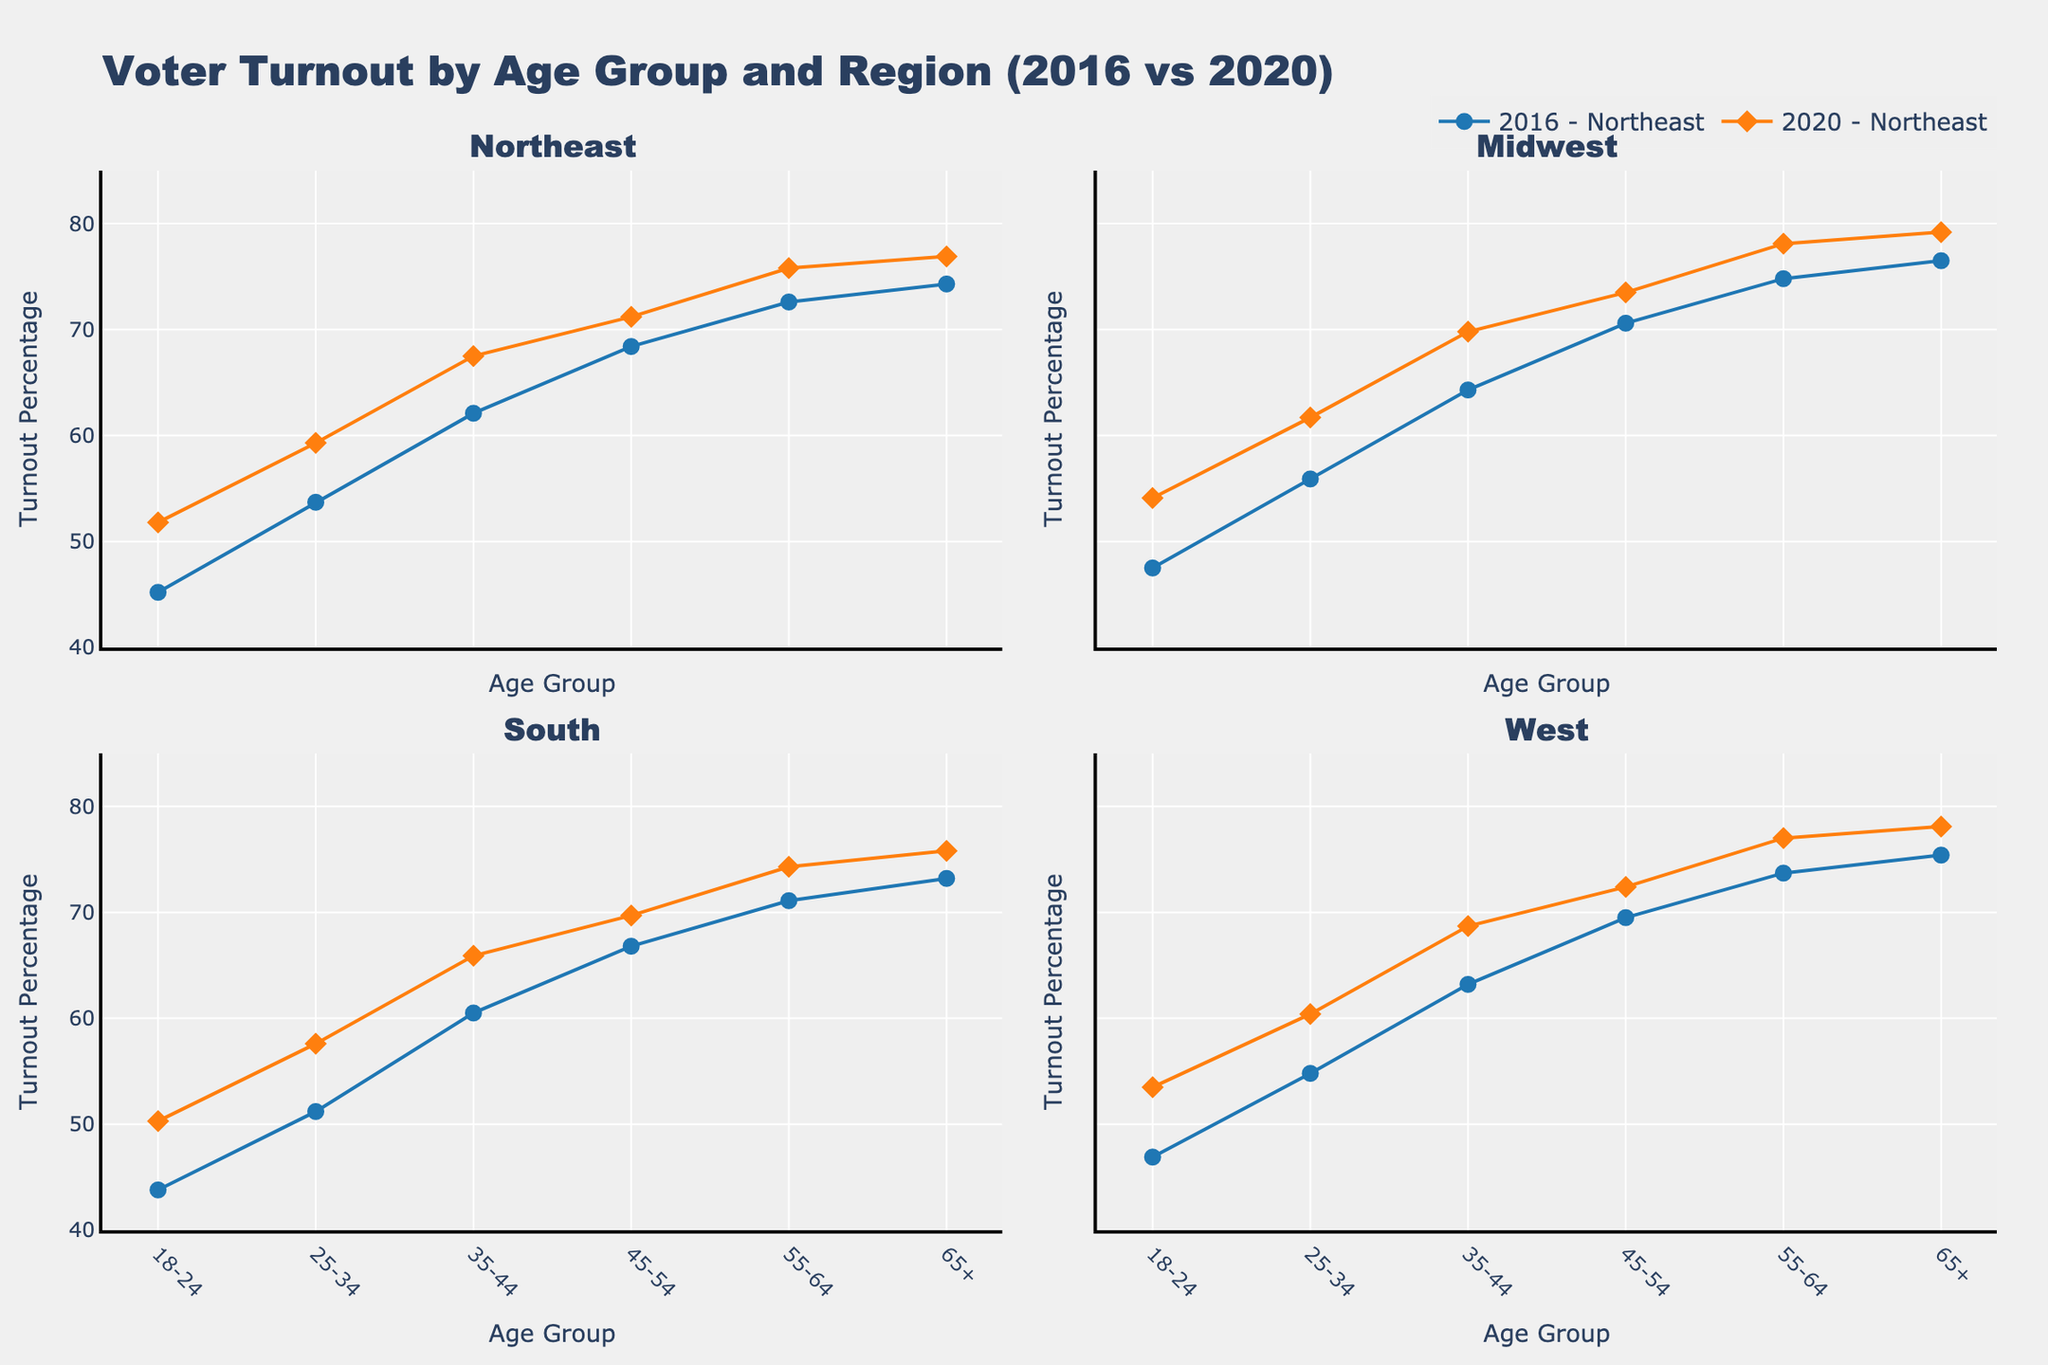Which category has the largest share of expenses in January? Looking at the pie chart for January, the largest share of expenses is indicated by the segment with the biggest area. The "Staff Wages" segment is the largest.
Answer: Staff Wages What is the combined percentage of 'Rent' and 'Utilities' expenses in February? First, find the percentages for 'Rent' and 'Utilities' in the February pie chart. Sum those two percentages to get the combined percentage.
Answer: [Explanation needed to calculate the actual values] How do the staff wages expenses compare across the three months? Looking at the 'Staff Wages' segments in each of the pie charts, they all appear as the largest segment which indicates that 'Staff Wages' make up the largest share of expenses consistently in each month. The sizes appear slightly different in width but close in size.
Answer: Consistently high Did marketing expenses increase or decrease from January to March? Compare the size of the 'Marketing' segment in January, February, and March pie charts. The visual indicates that 'Marketing' expenses in March are slightly larger than January and February.
Answer: Increased Which month's 'Ingredients' expenses contribute the highest percentage? By comparing the 'Ingredients' segments across the three pie charts, the largest segment belongs to March.
Answer: March What is the average rent expense over the three months? Summing up the rent expenses for the three months (£1200, £1200, £1200) and dividing by 3 gives us the average rent expense. The average is (1200+1200+1200)/3 = £1200.
Answer: £1200 Which month had the smallest percentage for 'Equipment Maintenance'? Look at the 'Equipment Maintenance' segments for each month; the smallest segment among them is February.
Answer: February If we add January's 'Utilities' and 'Equipment Maintenance' expenses, how much would that be? January's 'Utilities' expense is £600 and 'Equipment Maintenance' is £200. Adding these together: £600 + £200 = £800.
Answer: £800 